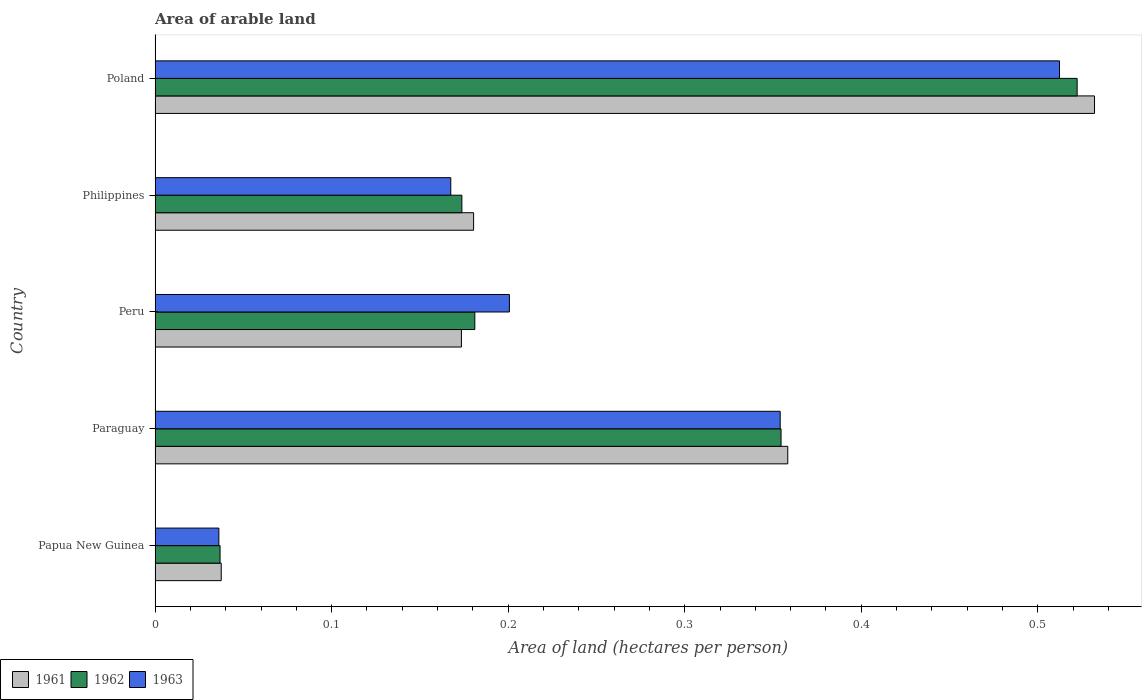Are the number of bars per tick equal to the number of legend labels?
Give a very brief answer. Yes. How many bars are there on the 4th tick from the top?
Your response must be concise. 3. How many bars are there on the 2nd tick from the bottom?
Give a very brief answer. 3. What is the total arable land in 1963 in Peru?
Offer a terse response. 0.2. Across all countries, what is the maximum total arable land in 1963?
Give a very brief answer. 0.51. Across all countries, what is the minimum total arable land in 1963?
Ensure brevity in your answer.  0.04. In which country was the total arable land in 1963 minimum?
Make the answer very short. Papua New Guinea. What is the total total arable land in 1961 in the graph?
Provide a succinct answer. 1.28. What is the difference between the total arable land in 1962 in Paraguay and that in Philippines?
Make the answer very short. 0.18. What is the difference between the total arable land in 1962 in Poland and the total arable land in 1961 in Paraguay?
Provide a short and direct response. 0.16. What is the average total arable land in 1961 per country?
Give a very brief answer. 0.26. What is the difference between the total arable land in 1961 and total arable land in 1963 in Paraguay?
Make the answer very short. 0. What is the ratio of the total arable land in 1962 in Papua New Guinea to that in Poland?
Make the answer very short. 0.07. Is the total arable land in 1962 in Papua New Guinea less than that in Poland?
Keep it short and to the point. Yes. Is the difference between the total arable land in 1961 in Peru and Poland greater than the difference between the total arable land in 1963 in Peru and Poland?
Your answer should be very brief. No. What is the difference between the highest and the second highest total arable land in 1961?
Keep it short and to the point. 0.17. What is the difference between the highest and the lowest total arable land in 1962?
Provide a short and direct response. 0.49. Is the sum of the total arable land in 1961 in Philippines and Poland greater than the maximum total arable land in 1962 across all countries?
Make the answer very short. Yes. Is it the case that in every country, the sum of the total arable land in 1963 and total arable land in 1961 is greater than the total arable land in 1962?
Your response must be concise. Yes. How many countries are there in the graph?
Your answer should be compact. 5. Are the values on the major ticks of X-axis written in scientific E-notation?
Provide a succinct answer. No. Does the graph contain any zero values?
Your response must be concise. No. Does the graph contain grids?
Your answer should be compact. No. How many legend labels are there?
Ensure brevity in your answer.  3. What is the title of the graph?
Your response must be concise. Area of arable land. Does "2002" appear as one of the legend labels in the graph?
Ensure brevity in your answer.  No. What is the label or title of the X-axis?
Provide a short and direct response. Area of land (hectares per person). What is the label or title of the Y-axis?
Provide a short and direct response. Country. What is the Area of land (hectares per person) of 1961 in Papua New Guinea?
Your answer should be compact. 0.04. What is the Area of land (hectares per person) of 1962 in Papua New Guinea?
Offer a terse response. 0.04. What is the Area of land (hectares per person) of 1963 in Papua New Guinea?
Provide a short and direct response. 0.04. What is the Area of land (hectares per person) in 1961 in Paraguay?
Make the answer very short. 0.36. What is the Area of land (hectares per person) of 1962 in Paraguay?
Your response must be concise. 0.35. What is the Area of land (hectares per person) in 1963 in Paraguay?
Give a very brief answer. 0.35. What is the Area of land (hectares per person) in 1961 in Peru?
Make the answer very short. 0.17. What is the Area of land (hectares per person) in 1962 in Peru?
Keep it short and to the point. 0.18. What is the Area of land (hectares per person) in 1963 in Peru?
Give a very brief answer. 0.2. What is the Area of land (hectares per person) in 1961 in Philippines?
Provide a succinct answer. 0.18. What is the Area of land (hectares per person) of 1962 in Philippines?
Your answer should be very brief. 0.17. What is the Area of land (hectares per person) of 1963 in Philippines?
Give a very brief answer. 0.17. What is the Area of land (hectares per person) in 1961 in Poland?
Offer a terse response. 0.53. What is the Area of land (hectares per person) of 1962 in Poland?
Keep it short and to the point. 0.52. What is the Area of land (hectares per person) in 1963 in Poland?
Your response must be concise. 0.51. Across all countries, what is the maximum Area of land (hectares per person) in 1961?
Keep it short and to the point. 0.53. Across all countries, what is the maximum Area of land (hectares per person) in 1962?
Your response must be concise. 0.52. Across all countries, what is the maximum Area of land (hectares per person) in 1963?
Ensure brevity in your answer.  0.51. Across all countries, what is the minimum Area of land (hectares per person) of 1961?
Your answer should be very brief. 0.04. Across all countries, what is the minimum Area of land (hectares per person) in 1962?
Provide a succinct answer. 0.04. Across all countries, what is the minimum Area of land (hectares per person) of 1963?
Your answer should be very brief. 0.04. What is the total Area of land (hectares per person) of 1961 in the graph?
Ensure brevity in your answer.  1.28. What is the total Area of land (hectares per person) of 1962 in the graph?
Make the answer very short. 1.27. What is the total Area of land (hectares per person) in 1963 in the graph?
Your answer should be very brief. 1.27. What is the difference between the Area of land (hectares per person) in 1961 in Papua New Guinea and that in Paraguay?
Provide a succinct answer. -0.32. What is the difference between the Area of land (hectares per person) of 1962 in Papua New Guinea and that in Paraguay?
Provide a succinct answer. -0.32. What is the difference between the Area of land (hectares per person) of 1963 in Papua New Guinea and that in Paraguay?
Your answer should be compact. -0.32. What is the difference between the Area of land (hectares per person) of 1961 in Papua New Guinea and that in Peru?
Provide a short and direct response. -0.14. What is the difference between the Area of land (hectares per person) of 1962 in Papua New Guinea and that in Peru?
Your answer should be very brief. -0.14. What is the difference between the Area of land (hectares per person) in 1963 in Papua New Guinea and that in Peru?
Your answer should be very brief. -0.16. What is the difference between the Area of land (hectares per person) in 1961 in Papua New Guinea and that in Philippines?
Your answer should be compact. -0.14. What is the difference between the Area of land (hectares per person) of 1962 in Papua New Guinea and that in Philippines?
Offer a terse response. -0.14. What is the difference between the Area of land (hectares per person) in 1963 in Papua New Guinea and that in Philippines?
Offer a terse response. -0.13. What is the difference between the Area of land (hectares per person) in 1961 in Papua New Guinea and that in Poland?
Your answer should be compact. -0.49. What is the difference between the Area of land (hectares per person) of 1962 in Papua New Guinea and that in Poland?
Provide a succinct answer. -0.49. What is the difference between the Area of land (hectares per person) in 1963 in Papua New Guinea and that in Poland?
Your response must be concise. -0.48. What is the difference between the Area of land (hectares per person) in 1961 in Paraguay and that in Peru?
Keep it short and to the point. 0.18. What is the difference between the Area of land (hectares per person) of 1962 in Paraguay and that in Peru?
Keep it short and to the point. 0.17. What is the difference between the Area of land (hectares per person) of 1963 in Paraguay and that in Peru?
Give a very brief answer. 0.15. What is the difference between the Area of land (hectares per person) of 1961 in Paraguay and that in Philippines?
Keep it short and to the point. 0.18. What is the difference between the Area of land (hectares per person) of 1962 in Paraguay and that in Philippines?
Provide a short and direct response. 0.18. What is the difference between the Area of land (hectares per person) of 1963 in Paraguay and that in Philippines?
Your answer should be compact. 0.19. What is the difference between the Area of land (hectares per person) of 1961 in Paraguay and that in Poland?
Your response must be concise. -0.17. What is the difference between the Area of land (hectares per person) in 1962 in Paraguay and that in Poland?
Provide a short and direct response. -0.17. What is the difference between the Area of land (hectares per person) in 1963 in Paraguay and that in Poland?
Offer a very short reply. -0.16. What is the difference between the Area of land (hectares per person) of 1961 in Peru and that in Philippines?
Give a very brief answer. -0.01. What is the difference between the Area of land (hectares per person) of 1962 in Peru and that in Philippines?
Your response must be concise. 0.01. What is the difference between the Area of land (hectares per person) of 1963 in Peru and that in Philippines?
Give a very brief answer. 0.03. What is the difference between the Area of land (hectares per person) in 1961 in Peru and that in Poland?
Your response must be concise. -0.36. What is the difference between the Area of land (hectares per person) of 1962 in Peru and that in Poland?
Ensure brevity in your answer.  -0.34. What is the difference between the Area of land (hectares per person) in 1963 in Peru and that in Poland?
Ensure brevity in your answer.  -0.31. What is the difference between the Area of land (hectares per person) of 1961 in Philippines and that in Poland?
Make the answer very short. -0.35. What is the difference between the Area of land (hectares per person) in 1962 in Philippines and that in Poland?
Offer a very short reply. -0.35. What is the difference between the Area of land (hectares per person) of 1963 in Philippines and that in Poland?
Provide a short and direct response. -0.34. What is the difference between the Area of land (hectares per person) of 1961 in Papua New Guinea and the Area of land (hectares per person) of 1962 in Paraguay?
Your answer should be compact. -0.32. What is the difference between the Area of land (hectares per person) of 1961 in Papua New Guinea and the Area of land (hectares per person) of 1963 in Paraguay?
Your answer should be very brief. -0.32. What is the difference between the Area of land (hectares per person) of 1962 in Papua New Guinea and the Area of land (hectares per person) of 1963 in Paraguay?
Offer a very short reply. -0.32. What is the difference between the Area of land (hectares per person) in 1961 in Papua New Guinea and the Area of land (hectares per person) in 1962 in Peru?
Your answer should be compact. -0.14. What is the difference between the Area of land (hectares per person) of 1961 in Papua New Guinea and the Area of land (hectares per person) of 1963 in Peru?
Your answer should be compact. -0.16. What is the difference between the Area of land (hectares per person) in 1962 in Papua New Guinea and the Area of land (hectares per person) in 1963 in Peru?
Your answer should be very brief. -0.16. What is the difference between the Area of land (hectares per person) in 1961 in Papua New Guinea and the Area of land (hectares per person) in 1962 in Philippines?
Ensure brevity in your answer.  -0.14. What is the difference between the Area of land (hectares per person) in 1961 in Papua New Guinea and the Area of land (hectares per person) in 1963 in Philippines?
Make the answer very short. -0.13. What is the difference between the Area of land (hectares per person) in 1962 in Papua New Guinea and the Area of land (hectares per person) in 1963 in Philippines?
Provide a succinct answer. -0.13. What is the difference between the Area of land (hectares per person) in 1961 in Papua New Guinea and the Area of land (hectares per person) in 1962 in Poland?
Your answer should be compact. -0.48. What is the difference between the Area of land (hectares per person) of 1961 in Papua New Guinea and the Area of land (hectares per person) of 1963 in Poland?
Keep it short and to the point. -0.47. What is the difference between the Area of land (hectares per person) of 1962 in Papua New Guinea and the Area of land (hectares per person) of 1963 in Poland?
Offer a terse response. -0.48. What is the difference between the Area of land (hectares per person) in 1961 in Paraguay and the Area of land (hectares per person) in 1962 in Peru?
Provide a succinct answer. 0.18. What is the difference between the Area of land (hectares per person) in 1961 in Paraguay and the Area of land (hectares per person) in 1963 in Peru?
Offer a terse response. 0.16. What is the difference between the Area of land (hectares per person) of 1962 in Paraguay and the Area of land (hectares per person) of 1963 in Peru?
Your response must be concise. 0.15. What is the difference between the Area of land (hectares per person) of 1961 in Paraguay and the Area of land (hectares per person) of 1962 in Philippines?
Offer a terse response. 0.18. What is the difference between the Area of land (hectares per person) in 1961 in Paraguay and the Area of land (hectares per person) in 1963 in Philippines?
Provide a short and direct response. 0.19. What is the difference between the Area of land (hectares per person) of 1962 in Paraguay and the Area of land (hectares per person) of 1963 in Philippines?
Offer a very short reply. 0.19. What is the difference between the Area of land (hectares per person) in 1961 in Paraguay and the Area of land (hectares per person) in 1962 in Poland?
Offer a terse response. -0.16. What is the difference between the Area of land (hectares per person) of 1961 in Paraguay and the Area of land (hectares per person) of 1963 in Poland?
Make the answer very short. -0.15. What is the difference between the Area of land (hectares per person) in 1962 in Paraguay and the Area of land (hectares per person) in 1963 in Poland?
Offer a terse response. -0.16. What is the difference between the Area of land (hectares per person) in 1961 in Peru and the Area of land (hectares per person) in 1962 in Philippines?
Offer a very short reply. -0. What is the difference between the Area of land (hectares per person) in 1961 in Peru and the Area of land (hectares per person) in 1963 in Philippines?
Give a very brief answer. 0.01. What is the difference between the Area of land (hectares per person) in 1962 in Peru and the Area of land (hectares per person) in 1963 in Philippines?
Provide a succinct answer. 0.01. What is the difference between the Area of land (hectares per person) in 1961 in Peru and the Area of land (hectares per person) in 1962 in Poland?
Provide a short and direct response. -0.35. What is the difference between the Area of land (hectares per person) in 1961 in Peru and the Area of land (hectares per person) in 1963 in Poland?
Keep it short and to the point. -0.34. What is the difference between the Area of land (hectares per person) in 1962 in Peru and the Area of land (hectares per person) in 1963 in Poland?
Give a very brief answer. -0.33. What is the difference between the Area of land (hectares per person) in 1961 in Philippines and the Area of land (hectares per person) in 1962 in Poland?
Your answer should be very brief. -0.34. What is the difference between the Area of land (hectares per person) in 1961 in Philippines and the Area of land (hectares per person) in 1963 in Poland?
Provide a short and direct response. -0.33. What is the difference between the Area of land (hectares per person) in 1962 in Philippines and the Area of land (hectares per person) in 1963 in Poland?
Offer a terse response. -0.34. What is the average Area of land (hectares per person) in 1961 per country?
Offer a very short reply. 0.26. What is the average Area of land (hectares per person) of 1962 per country?
Your response must be concise. 0.25. What is the average Area of land (hectares per person) in 1963 per country?
Provide a succinct answer. 0.25. What is the difference between the Area of land (hectares per person) of 1961 and Area of land (hectares per person) of 1962 in Papua New Guinea?
Offer a terse response. 0. What is the difference between the Area of land (hectares per person) of 1961 and Area of land (hectares per person) of 1963 in Papua New Guinea?
Offer a very short reply. 0. What is the difference between the Area of land (hectares per person) of 1962 and Area of land (hectares per person) of 1963 in Papua New Guinea?
Provide a short and direct response. 0. What is the difference between the Area of land (hectares per person) of 1961 and Area of land (hectares per person) of 1962 in Paraguay?
Give a very brief answer. 0. What is the difference between the Area of land (hectares per person) in 1961 and Area of land (hectares per person) in 1963 in Paraguay?
Give a very brief answer. 0. What is the difference between the Area of land (hectares per person) in 1961 and Area of land (hectares per person) in 1962 in Peru?
Provide a succinct answer. -0.01. What is the difference between the Area of land (hectares per person) of 1961 and Area of land (hectares per person) of 1963 in Peru?
Your answer should be very brief. -0.03. What is the difference between the Area of land (hectares per person) in 1962 and Area of land (hectares per person) in 1963 in Peru?
Offer a terse response. -0.02. What is the difference between the Area of land (hectares per person) of 1961 and Area of land (hectares per person) of 1962 in Philippines?
Your answer should be compact. 0.01. What is the difference between the Area of land (hectares per person) of 1961 and Area of land (hectares per person) of 1963 in Philippines?
Offer a very short reply. 0.01. What is the difference between the Area of land (hectares per person) of 1962 and Area of land (hectares per person) of 1963 in Philippines?
Your answer should be compact. 0.01. What is the difference between the Area of land (hectares per person) of 1961 and Area of land (hectares per person) of 1962 in Poland?
Provide a short and direct response. 0.01. What is the difference between the Area of land (hectares per person) of 1961 and Area of land (hectares per person) of 1963 in Poland?
Keep it short and to the point. 0.02. What is the ratio of the Area of land (hectares per person) of 1961 in Papua New Guinea to that in Paraguay?
Provide a short and direct response. 0.1. What is the ratio of the Area of land (hectares per person) of 1962 in Papua New Guinea to that in Paraguay?
Offer a very short reply. 0.1. What is the ratio of the Area of land (hectares per person) of 1963 in Papua New Guinea to that in Paraguay?
Ensure brevity in your answer.  0.1. What is the ratio of the Area of land (hectares per person) in 1961 in Papua New Guinea to that in Peru?
Your answer should be compact. 0.22. What is the ratio of the Area of land (hectares per person) of 1962 in Papua New Guinea to that in Peru?
Your answer should be compact. 0.2. What is the ratio of the Area of land (hectares per person) of 1963 in Papua New Guinea to that in Peru?
Keep it short and to the point. 0.18. What is the ratio of the Area of land (hectares per person) of 1961 in Papua New Guinea to that in Philippines?
Make the answer very short. 0.21. What is the ratio of the Area of land (hectares per person) of 1962 in Papua New Guinea to that in Philippines?
Provide a short and direct response. 0.21. What is the ratio of the Area of land (hectares per person) in 1963 in Papua New Guinea to that in Philippines?
Provide a succinct answer. 0.22. What is the ratio of the Area of land (hectares per person) of 1961 in Papua New Guinea to that in Poland?
Offer a very short reply. 0.07. What is the ratio of the Area of land (hectares per person) of 1962 in Papua New Guinea to that in Poland?
Make the answer very short. 0.07. What is the ratio of the Area of land (hectares per person) in 1963 in Papua New Guinea to that in Poland?
Your response must be concise. 0.07. What is the ratio of the Area of land (hectares per person) of 1961 in Paraguay to that in Peru?
Your answer should be very brief. 2.07. What is the ratio of the Area of land (hectares per person) of 1962 in Paraguay to that in Peru?
Your answer should be very brief. 1.96. What is the ratio of the Area of land (hectares per person) of 1963 in Paraguay to that in Peru?
Provide a succinct answer. 1.76. What is the ratio of the Area of land (hectares per person) of 1961 in Paraguay to that in Philippines?
Offer a very short reply. 1.99. What is the ratio of the Area of land (hectares per person) in 1962 in Paraguay to that in Philippines?
Your answer should be compact. 2.04. What is the ratio of the Area of land (hectares per person) in 1963 in Paraguay to that in Philippines?
Ensure brevity in your answer.  2.11. What is the ratio of the Area of land (hectares per person) of 1961 in Paraguay to that in Poland?
Your answer should be compact. 0.67. What is the ratio of the Area of land (hectares per person) in 1962 in Paraguay to that in Poland?
Offer a very short reply. 0.68. What is the ratio of the Area of land (hectares per person) of 1963 in Paraguay to that in Poland?
Ensure brevity in your answer.  0.69. What is the ratio of the Area of land (hectares per person) of 1961 in Peru to that in Philippines?
Make the answer very short. 0.96. What is the ratio of the Area of land (hectares per person) in 1962 in Peru to that in Philippines?
Give a very brief answer. 1.04. What is the ratio of the Area of land (hectares per person) in 1963 in Peru to that in Philippines?
Your answer should be compact. 1.2. What is the ratio of the Area of land (hectares per person) in 1961 in Peru to that in Poland?
Provide a short and direct response. 0.33. What is the ratio of the Area of land (hectares per person) of 1962 in Peru to that in Poland?
Ensure brevity in your answer.  0.35. What is the ratio of the Area of land (hectares per person) of 1963 in Peru to that in Poland?
Your answer should be compact. 0.39. What is the ratio of the Area of land (hectares per person) of 1961 in Philippines to that in Poland?
Provide a succinct answer. 0.34. What is the ratio of the Area of land (hectares per person) of 1962 in Philippines to that in Poland?
Your answer should be compact. 0.33. What is the ratio of the Area of land (hectares per person) of 1963 in Philippines to that in Poland?
Make the answer very short. 0.33. What is the difference between the highest and the second highest Area of land (hectares per person) of 1961?
Provide a short and direct response. 0.17. What is the difference between the highest and the second highest Area of land (hectares per person) in 1962?
Offer a very short reply. 0.17. What is the difference between the highest and the second highest Area of land (hectares per person) of 1963?
Offer a very short reply. 0.16. What is the difference between the highest and the lowest Area of land (hectares per person) in 1961?
Your response must be concise. 0.49. What is the difference between the highest and the lowest Area of land (hectares per person) of 1962?
Make the answer very short. 0.49. What is the difference between the highest and the lowest Area of land (hectares per person) of 1963?
Provide a short and direct response. 0.48. 